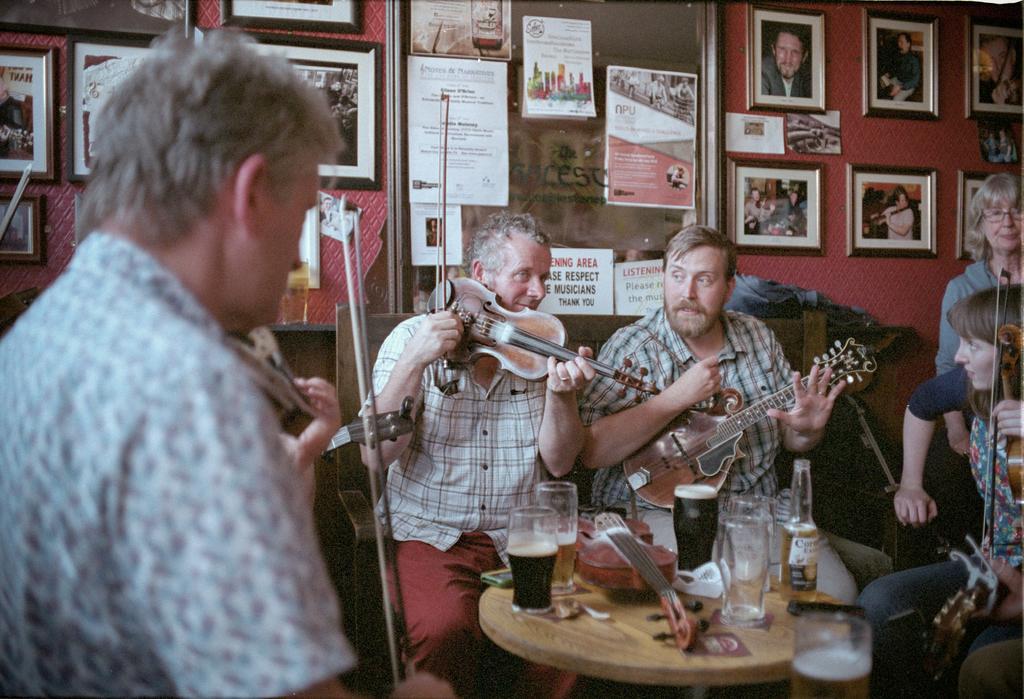Please provide a concise description of this image. There are group of people playing violin and there is a table in front of them which contains a glass of drink in it. 